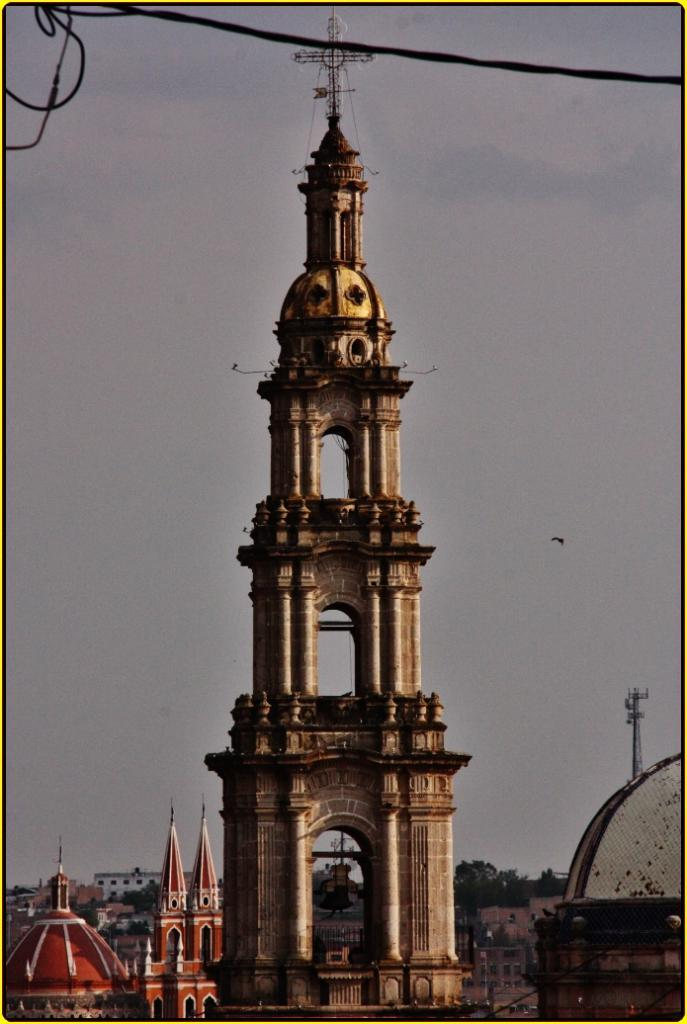What is the main structure in the front of the image? There is a tower in the front of the image. What is on top of the tower? There is a wire on top of the tower. What can be seen in the background of the image? There are buildings in the background of the image. How would you describe the sky in the image? The sky is cloudy in the image. How many women are sitting on the grass in the image? There is no grass or women present in the image; it features a tower with a wire on top and buildings in the background. 